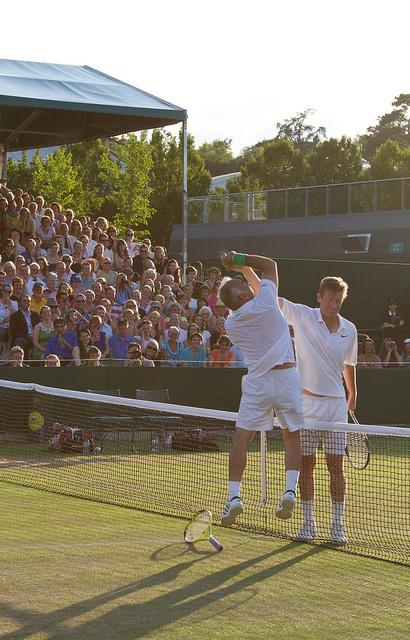What is the profession of the men in white?

Choices:
A) athletes
B) nurses
C) doctors
D) teachers athletes 